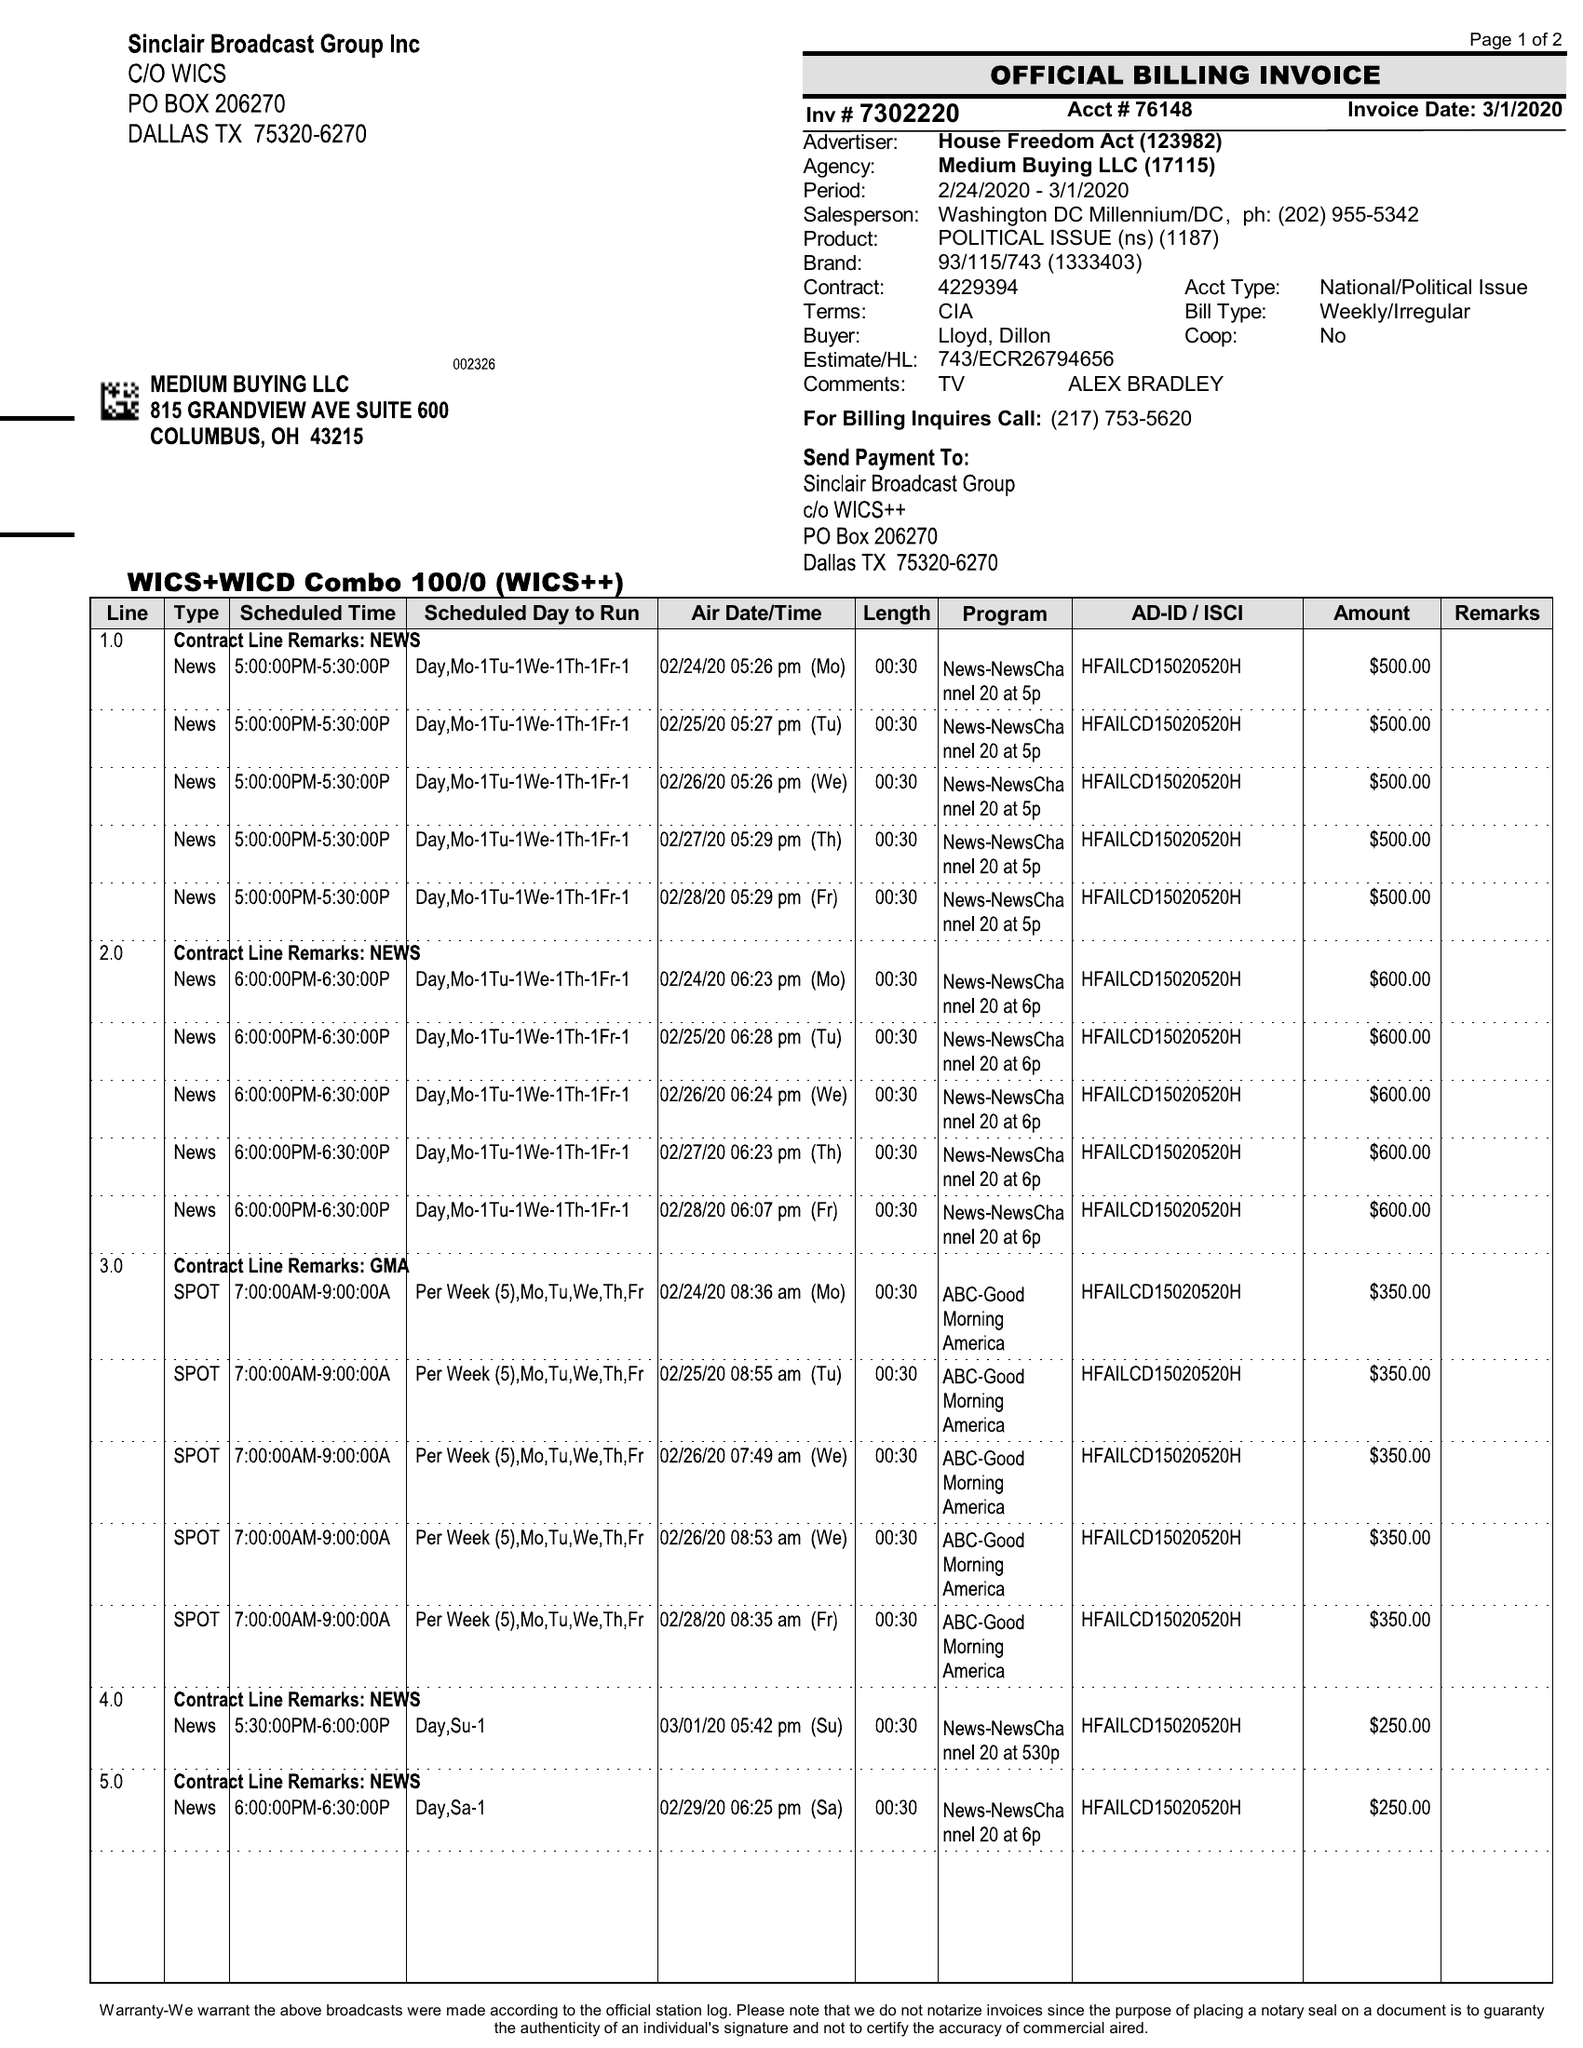What is the value for the flight_from?
Answer the question using a single word or phrase. 02/24/20 